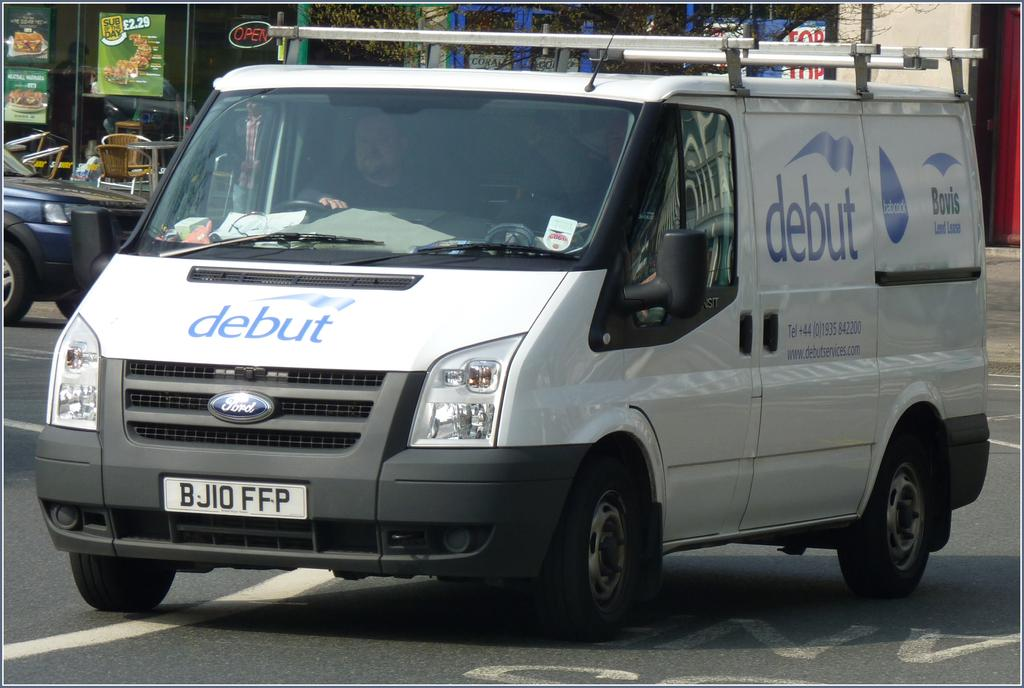<image>
Present a compact description of the photo's key features. A white van is for the company Debut. 